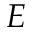<formula> <loc_0><loc_0><loc_500><loc_500>E</formula> 